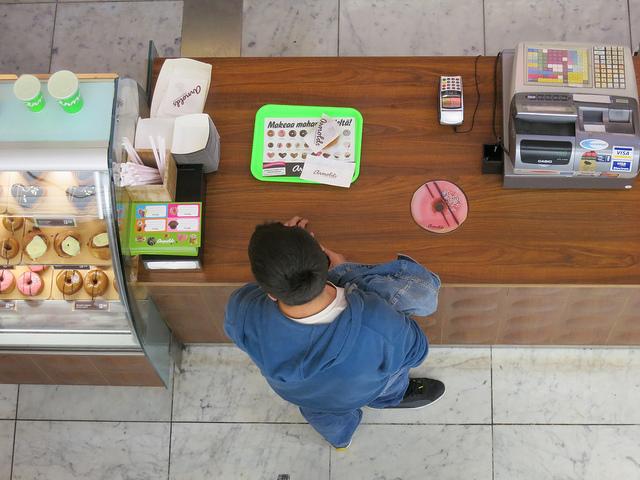Does this business accept credit or debit cards?
Keep it brief. Yes. Does this man know he's being filmed?
Give a very brief answer. No. Where are the donuts?
Be succinct. In case. How many cups are on top of the display case?
Write a very short answer. 2. 